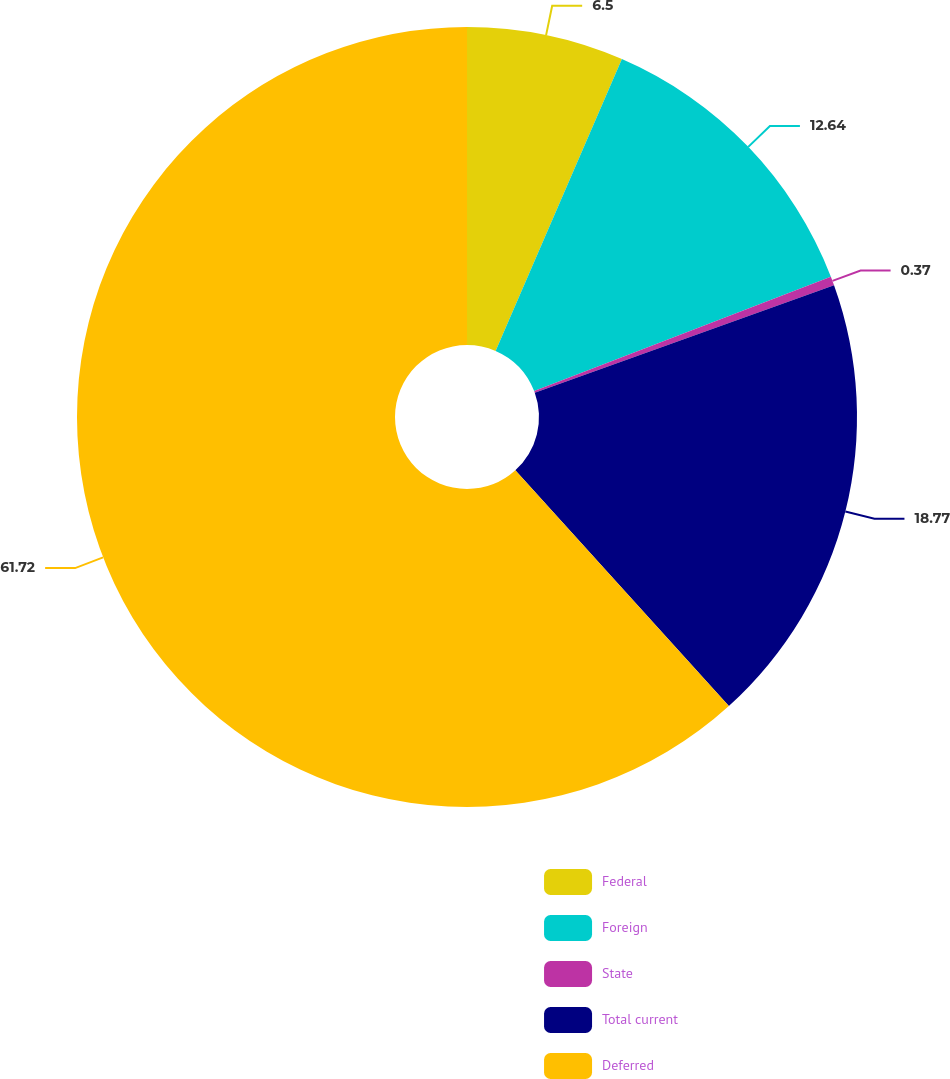Convert chart to OTSL. <chart><loc_0><loc_0><loc_500><loc_500><pie_chart><fcel>Federal<fcel>Foreign<fcel>State<fcel>Total current<fcel>Deferred<nl><fcel>6.5%<fcel>12.64%<fcel>0.37%<fcel>18.77%<fcel>61.71%<nl></chart> 